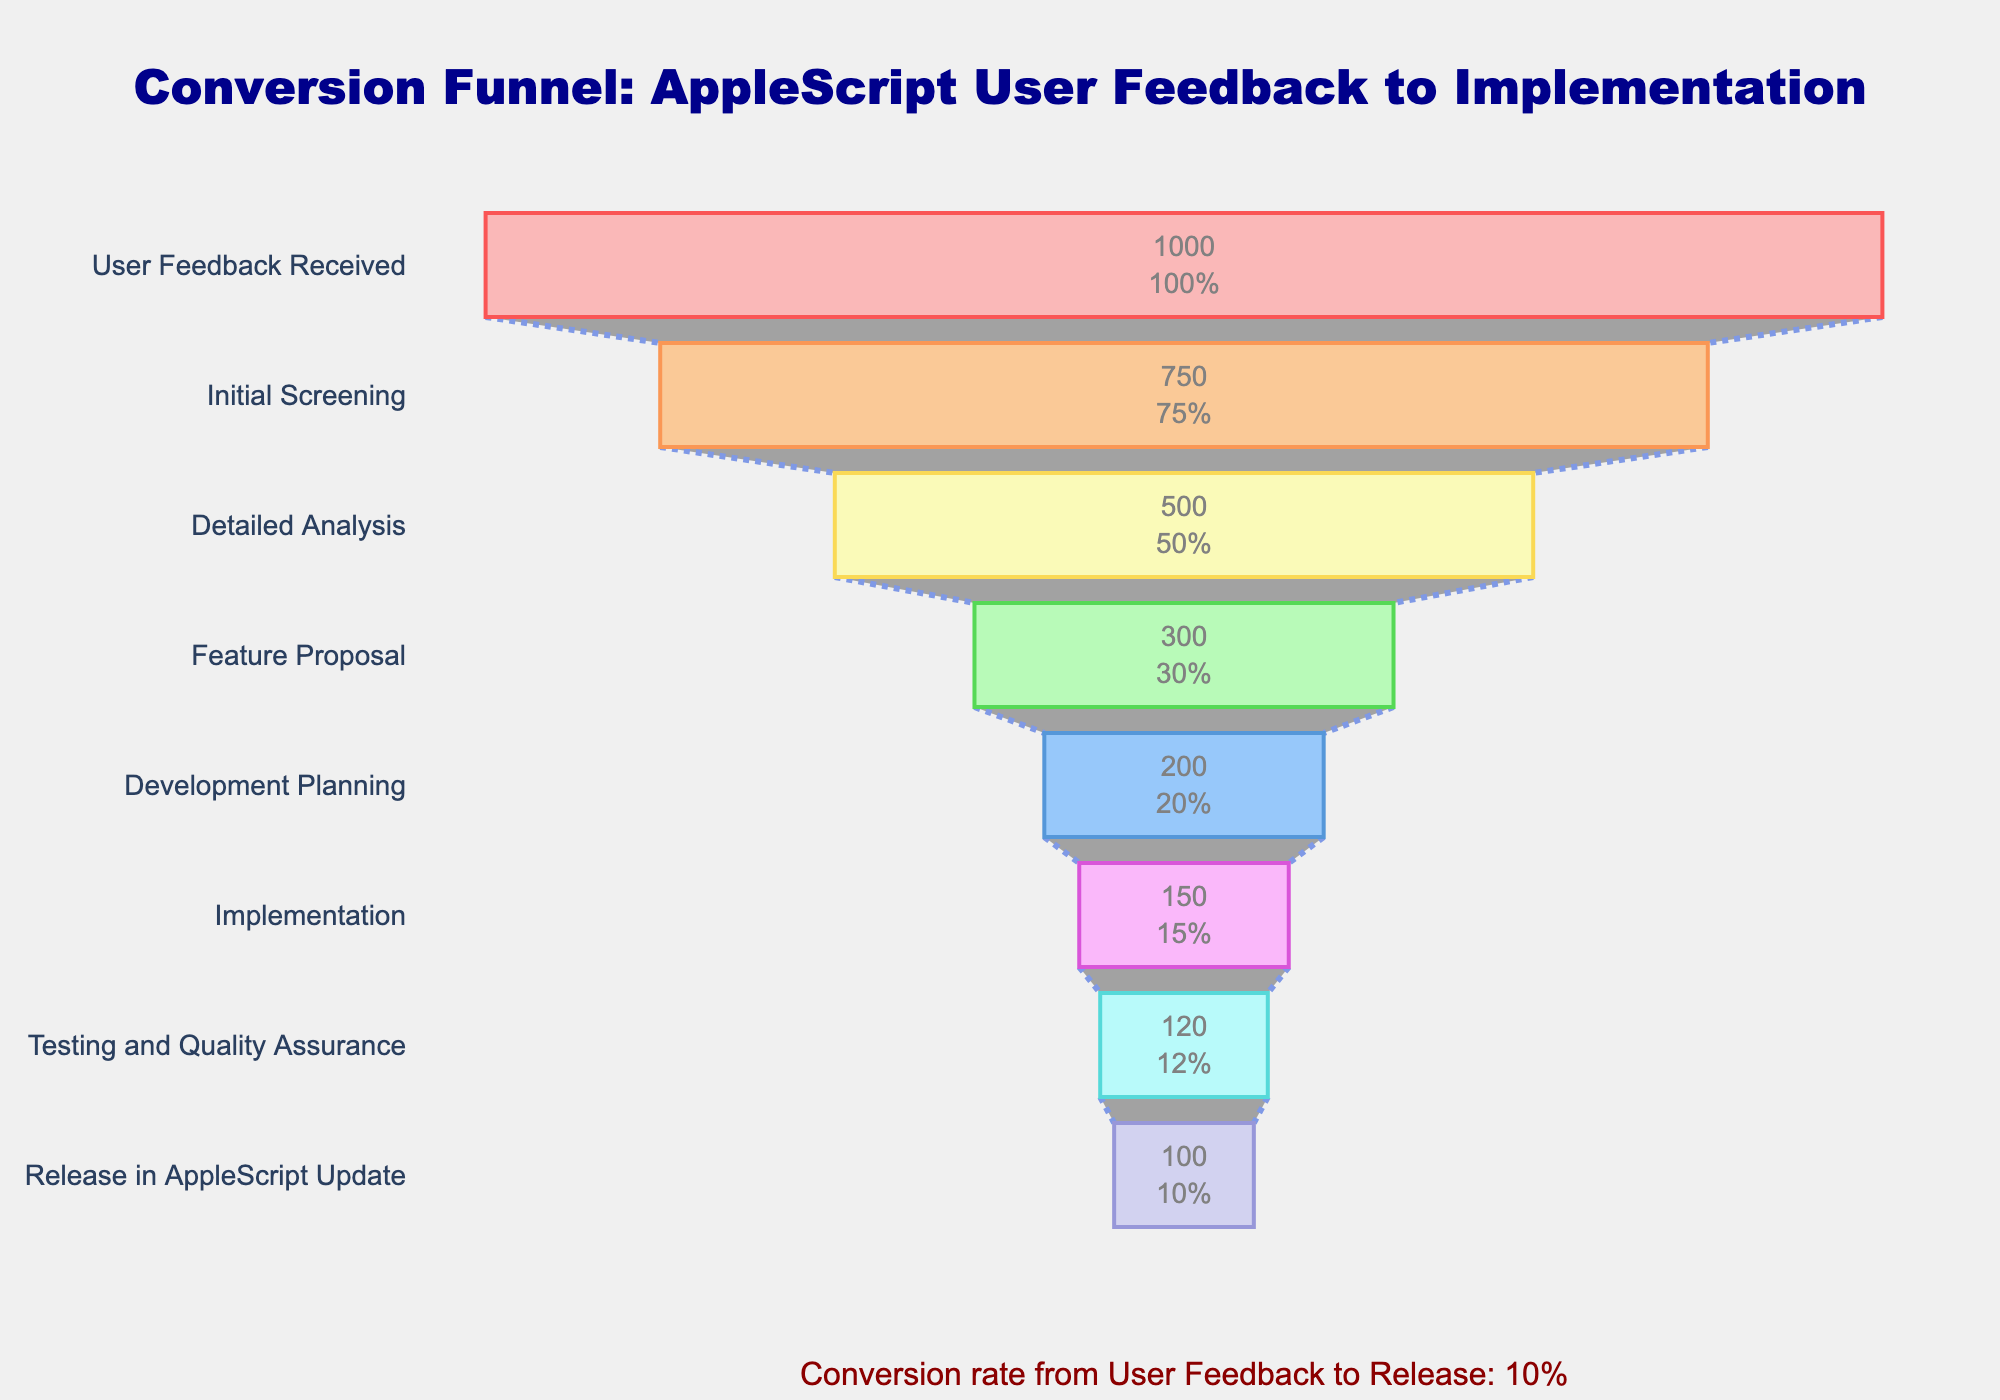what is the title of the figure? The figure’s title is located at the top center and contains large text. It provides context for what the chart represents.
Answer: Conversion Funnel: AppleScript User Feedback to Implementation How many stages are there in the funnel? Counting the number of distinct stages listed on the y-axis of the chart tells us how many different steps are represented.
Answer: 8 Which stage has the highest count? Identify the stage with the longest bar on the x-axis since a longer bar means a higher count.
Answer: User Feedback Received How many counts are at the Development Planning stage? Locate "Development Planning" on the y-axis and see the corresponding value on the x-axis.
Answer: 200 What is the percentage of feedback that passes the Initial Screening stage? The funnel chart often shows percentage values along with absolute counts on the stage bars. Look for the percentage label on the "Initial Screening" stage bar.
Answer: 75% How many total counts get screened out in the Initial Screening Stage? Subtract the count of the Initial Screening stage from the User Feedback Received stage to determine how many were screened out. 1000 - 750 = 250
Answer: 250 What’s the difference in count between the Detailed Analysis and Feature Proposal stages? Locate the counts for both Detailed Analysis (500) and Feature Proposal (300) stages on the chart and subtract the latter from the former. 500 - 300 = 200
Answer: 200 Which stage has the lowest count and therefore the steepest drop from the previous stage? Compare the lengths of all the bars and then identify the stage with the shortest bar, indicating the lowest count. Also, consider the steepest drop by comparing it to the previous stage.
Answer: Release in AppleScript Update What is the conversion rate from Feedback Received to Final Release? Calculate the conversion rate by dividing the final stage count (Release in AppleScript Update) by the initial stage count (User Feedback Received) and then multiply by 100 to get the percentage. 100/1000 * 100 = 10%
Answer: 10% How many counts proceed from Testing and Quality Assurance to Release in AppleScript Update? Identify the counts of both stages and subtract the final stage count from the penultimate stage count. 120 - 100 = 20
Answer: 20 